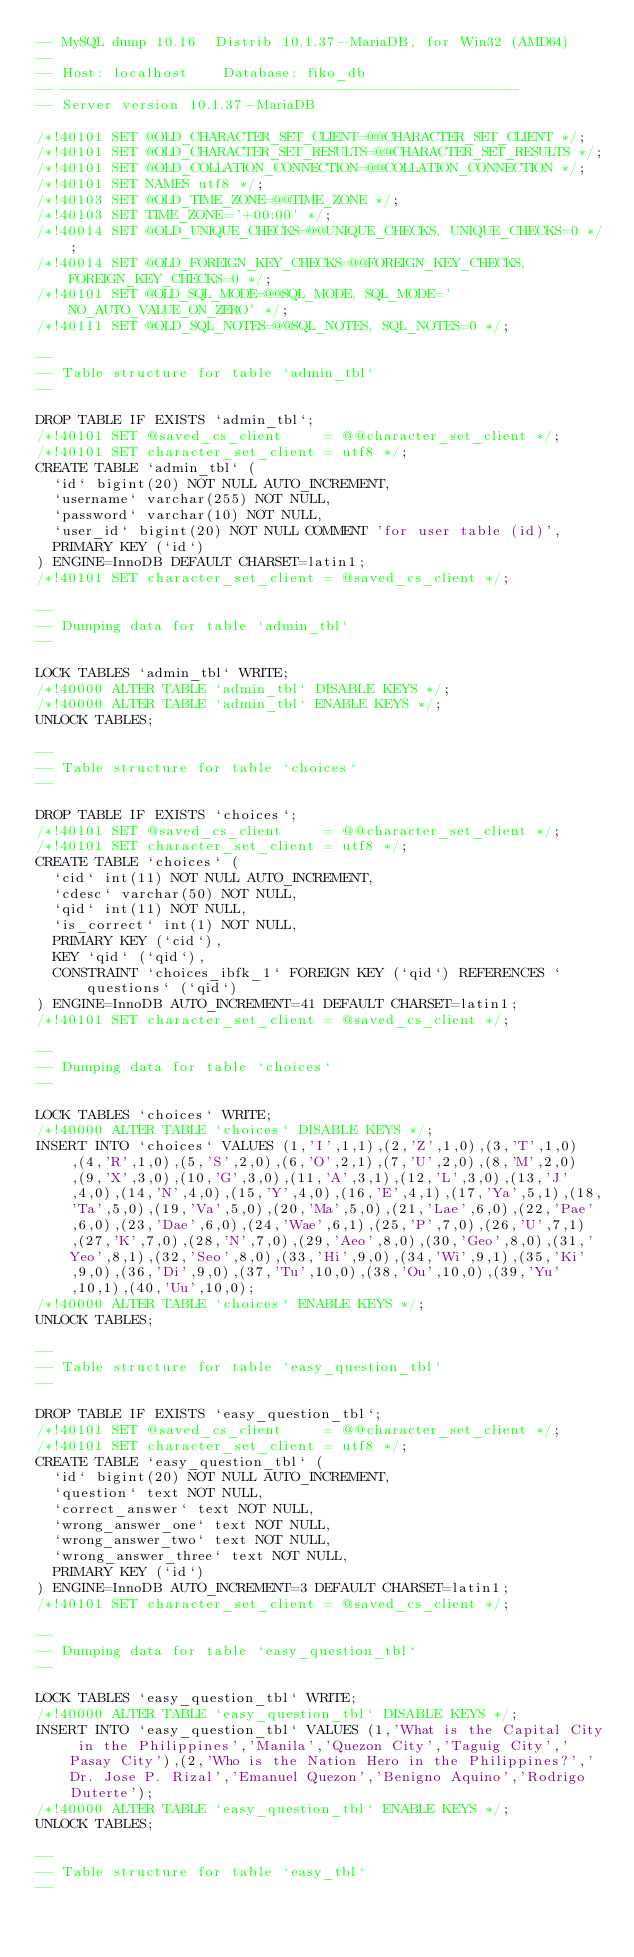Convert code to text. <code><loc_0><loc_0><loc_500><loc_500><_SQL_>-- MySQL dump 10.16  Distrib 10.1.37-MariaDB, for Win32 (AMD64)
--
-- Host: localhost    Database: fiko_db
-- ------------------------------------------------------
-- Server version	10.1.37-MariaDB

/*!40101 SET @OLD_CHARACTER_SET_CLIENT=@@CHARACTER_SET_CLIENT */;
/*!40101 SET @OLD_CHARACTER_SET_RESULTS=@@CHARACTER_SET_RESULTS */;
/*!40101 SET @OLD_COLLATION_CONNECTION=@@COLLATION_CONNECTION */;
/*!40101 SET NAMES utf8 */;
/*!40103 SET @OLD_TIME_ZONE=@@TIME_ZONE */;
/*!40103 SET TIME_ZONE='+00:00' */;
/*!40014 SET @OLD_UNIQUE_CHECKS=@@UNIQUE_CHECKS, UNIQUE_CHECKS=0 */;
/*!40014 SET @OLD_FOREIGN_KEY_CHECKS=@@FOREIGN_KEY_CHECKS, FOREIGN_KEY_CHECKS=0 */;
/*!40101 SET @OLD_SQL_MODE=@@SQL_MODE, SQL_MODE='NO_AUTO_VALUE_ON_ZERO' */;
/*!40111 SET @OLD_SQL_NOTES=@@SQL_NOTES, SQL_NOTES=0 */;

--
-- Table structure for table `admin_tbl`
--

DROP TABLE IF EXISTS `admin_tbl`;
/*!40101 SET @saved_cs_client     = @@character_set_client */;
/*!40101 SET character_set_client = utf8 */;
CREATE TABLE `admin_tbl` (
  `id` bigint(20) NOT NULL AUTO_INCREMENT,
  `username` varchar(255) NOT NULL,
  `password` varchar(10) NOT NULL,
  `user_id` bigint(20) NOT NULL COMMENT 'for user table (id)',
  PRIMARY KEY (`id`)
) ENGINE=InnoDB DEFAULT CHARSET=latin1;
/*!40101 SET character_set_client = @saved_cs_client */;

--
-- Dumping data for table `admin_tbl`
--

LOCK TABLES `admin_tbl` WRITE;
/*!40000 ALTER TABLE `admin_tbl` DISABLE KEYS */;
/*!40000 ALTER TABLE `admin_tbl` ENABLE KEYS */;
UNLOCK TABLES;

--
-- Table structure for table `choices`
--

DROP TABLE IF EXISTS `choices`;
/*!40101 SET @saved_cs_client     = @@character_set_client */;
/*!40101 SET character_set_client = utf8 */;
CREATE TABLE `choices` (
  `cid` int(11) NOT NULL AUTO_INCREMENT,
  `cdesc` varchar(50) NOT NULL,
  `qid` int(11) NOT NULL,
  `is_correct` int(1) NOT NULL,
  PRIMARY KEY (`cid`),
  KEY `qid` (`qid`),
  CONSTRAINT `choices_ibfk_1` FOREIGN KEY (`qid`) REFERENCES `questions` (`qid`)
) ENGINE=InnoDB AUTO_INCREMENT=41 DEFAULT CHARSET=latin1;
/*!40101 SET character_set_client = @saved_cs_client */;

--
-- Dumping data for table `choices`
--

LOCK TABLES `choices` WRITE;
/*!40000 ALTER TABLE `choices` DISABLE KEYS */;
INSERT INTO `choices` VALUES (1,'I',1,1),(2,'Z',1,0),(3,'T',1,0),(4,'R',1,0),(5,'S',2,0),(6,'O',2,1),(7,'U',2,0),(8,'M',2,0),(9,'X',3,0),(10,'G',3,0),(11,'A',3,1),(12,'L',3,0),(13,'J',4,0),(14,'N',4,0),(15,'Y',4,0),(16,'E',4,1),(17,'Ya',5,1),(18,'Ta',5,0),(19,'Va',5,0),(20,'Ma',5,0),(21,'Lae',6,0),(22,'Pae',6,0),(23,'Dae',6,0),(24,'Wae',6,1),(25,'P',7,0),(26,'U',7,1),(27,'K',7,0),(28,'N',7,0),(29,'Aeo',8,0),(30,'Geo',8,0),(31,'Yeo',8,1),(32,'Seo',8,0),(33,'Hi',9,0),(34,'Wi',9,1),(35,'Ki',9,0),(36,'Di',9,0),(37,'Tu',10,0),(38,'Ou',10,0),(39,'Yu',10,1),(40,'Uu',10,0);
/*!40000 ALTER TABLE `choices` ENABLE KEYS */;
UNLOCK TABLES;

--
-- Table structure for table `easy_question_tbl`
--

DROP TABLE IF EXISTS `easy_question_tbl`;
/*!40101 SET @saved_cs_client     = @@character_set_client */;
/*!40101 SET character_set_client = utf8 */;
CREATE TABLE `easy_question_tbl` (
  `id` bigint(20) NOT NULL AUTO_INCREMENT,
  `question` text NOT NULL,
  `correct_answer` text NOT NULL,
  `wrong_answer_one` text NOT NULL,
  `wrong_answer_two` text NOT NULL,
  `wrong_answer_three` text NOT NULL,
  PRIMARY KEY (`id`)
) ENGINE=InnoDB AUTO_INCREMENT=3 DEFAULT CHARSET=latin1;
/*!40101 SET character_set_client = @saved_cs_client */;

--
-- Dumping data for table `easy_question_tbl`
--

LOCK TABLES `easy_question_tbl` WRITE;
/*!40000 ALTER TABLE `easy_question_tbl` DISABLE KEYS */;
INSERT INTO `easy_question_tbl` VALUES (1,'What is the Capital City in the Philippines','Manila','Quezon City','Taguig City','Pasay City'),(2,'Who is the Nation Hero in the Philippines?','Dr. Jose P. Rizal','Emanuel Quezon','Benigno Aquino','Rodrigo Duterte');
/*!40000 ALTER TABLE `easy_question_tbl` ENABLE KEYS */;
UNLOCK TABLES;

--
-- Table structure for table `easy_tbl`
--
</code> 